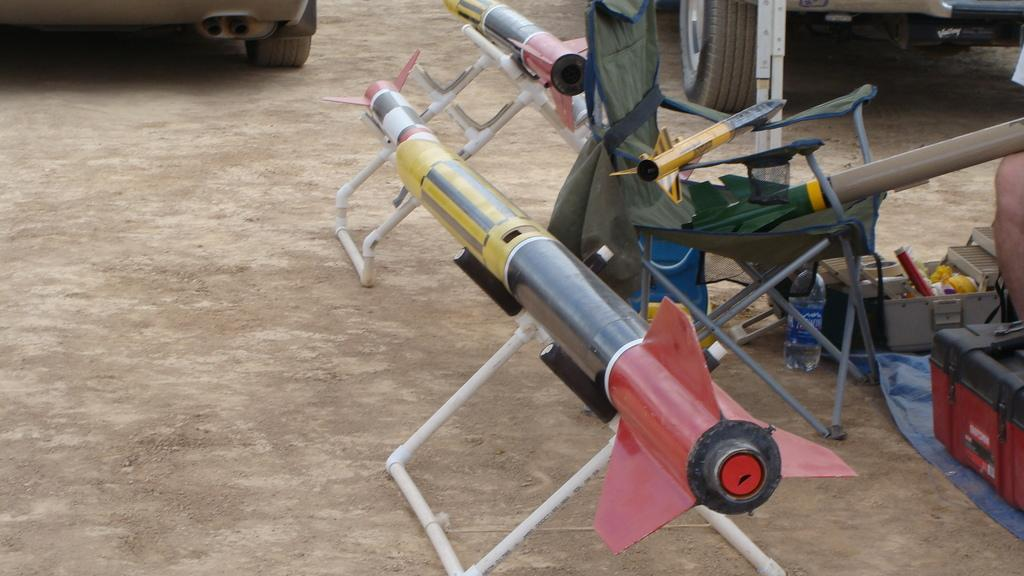What is located in the foreground of the image? There are rockets in the foreground of the image. What can be seen on the right side of the image? There are boxes and a person's leg visible on the right side of the image. What is located at the top of the image? There are vehicles at the top of the image. What type of surface is present in the image? Soil is present in the image. How much tax is being paid on the rockets in the image? There is no information about taxes in the image, as it focuses on rockets, boxes, a person's leg, vehicles, and soil. How many times does the person blow on the rockets in the image? There is no person blowing on the rockets in the image; the person's leg is visible, but no action is being performed. 